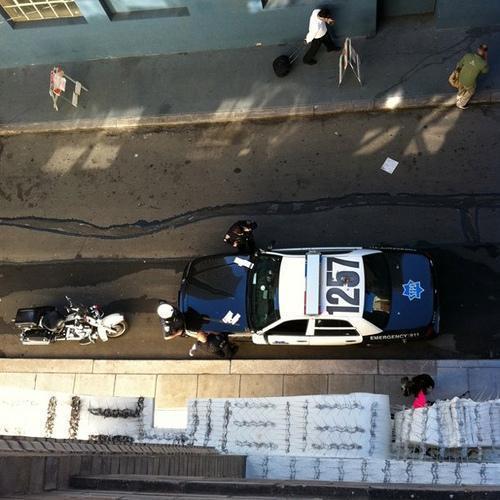How many cars?
Give a very brief answer. 1. 